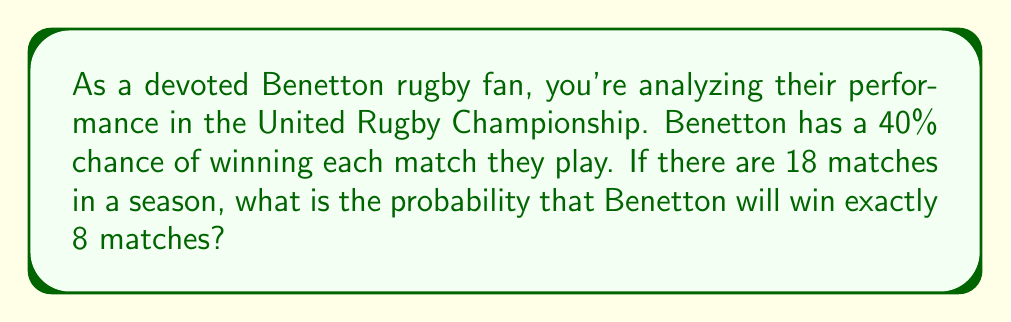Could you help me with this problem? To solve this problem, we need to use the binomial probability distribution. The binomial distribution is applicable when we have a fixed number of independent trials (matches), each with the same probability of success (winning).

Let's define our variables:
$n = 18$ (total number of matches)
$k = 8$ (number of wins we're interested in)
$p = 0.40$ (probability of winning a single match)
$q = 1 - p = 0.60$ (probability of losing a single match)

The probability of exactly $k$ successes in $n$ trials is given by the formula:

$$P(X = k) = \binom{n}{k} p^k q^{n-k}$$

Where $\binom{n}{k}$ is the binomial coefficient, calculated as:

$$\binom{n}{k} = \frac{n!}{k!(n-k)!}$$

Let's calculate step by step:

1) First, calculate the binomial coefficient:
   $$\binom{18}{8} = \frac{18!}{8!(18-8)!} = \frac{18!}{8!10!} = 43,758$$

2) Now, let's plug everything into our binomial probability formula:
   $$P(X = 8) = 43,758 \cdot (0.40)^8 \cdot (0.60)^{18-8}$$
   $$= 43,758 \cdot (0.40)^8 \cdot (0.60)^{10}$$

3) Calculate the powers:
   $$(0.40)^8 \approx 0.00065536$$
   $$(0.60)^{10} \approx 0.00604661$$

4) Multiply all parts together:
   $$43,758 \cdot 0.00065536 \cdot 0.00604661 \approx 0.1737$$

Therefore, the probability of Benetton winning exactly 8 matches out of 18 is approximately 0.1737 or 17.37%.
Answer: The probability of Benetton winning exactly 8 matches out of 18 is approximately 0.1737 or 17.37%. 